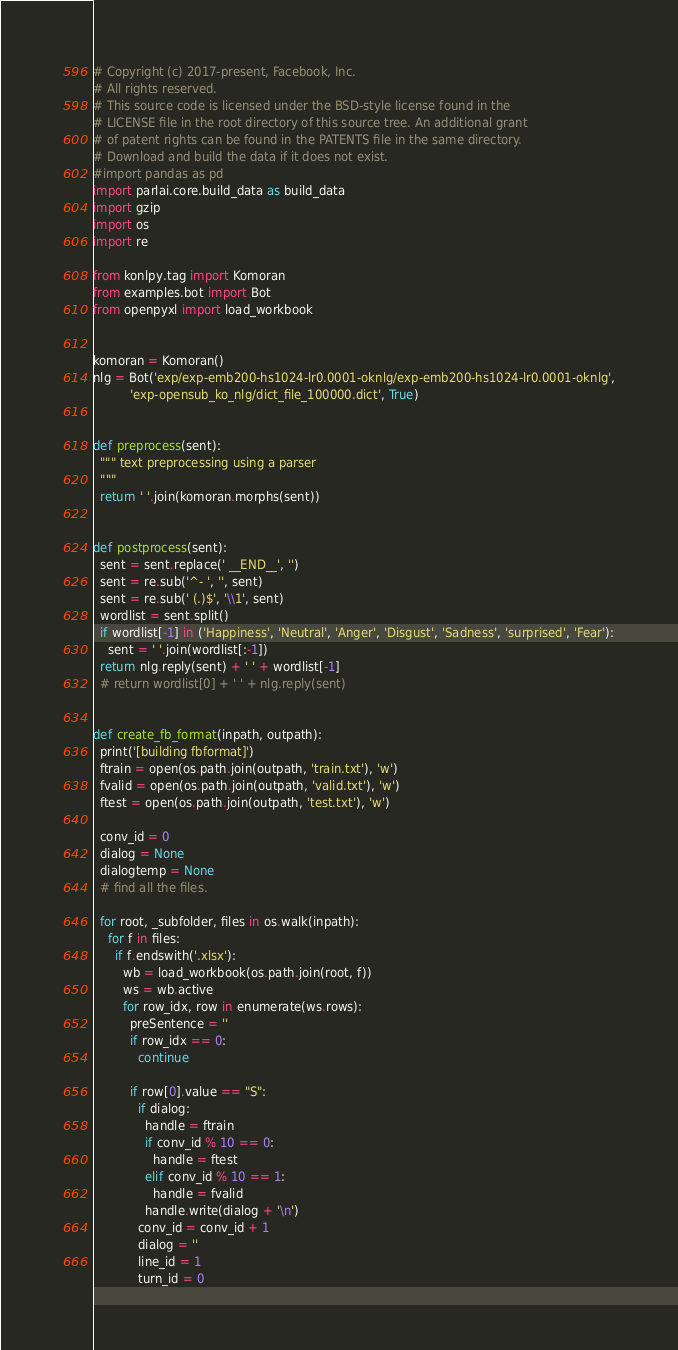Convert code to text. <code><loc_0><loc_0><loc_500><loc_500><_Python_># Copyright (c) 2017-present, Facebook, Inc.
# All rights reserved.
# This source code is licensed under the BSD-style license found in the
# LICENSE file in the root directory of this source tree. An additional grant
# of patent rights can be found in the PATENTS file in the same directory.
# Download and build the data if it does not exist.
#import pandas as pd
import parlai.core.build_data as build_data
import gzip
import os
import re

from konlpy.tag import Komoran
from examples.bot import Bot
from openpyxl import load_workbook


komoran = Komoran()
nlg = Bot('exp/exp-emb200-hs1024-lr0.0001-oknlg/exp-emb200-hs1024-lr0.0001-oknlg',
          'exp-opensub_ko_nlg/dict_file_100000.dict', True)


def preprocess(sent):
  """ text preprocessing using a parser
  """
  return ' '.join(komoran.morphs(sent))


def postprocess(sent):
  sent = sent.replace(' __END__', '')
  sent = re.sub('^- ', '', sent)
  sent = re.sub(' (.)$', '\\1', sent)
  wordlist = sent.split()
  if wordlist[-1] in ('Happiness', 'Neutral', 'Anger', 'Disgust', 'Sadness', 'surprised', 'Fear'):
    sent = ' '.join(wordlist[:-1])
  return nlg.reply(sent) + ' ' + wordlist[-1]
  # return wordlist[0] + ' ' + nlg.reply(sent)


def create_fb_format(inpath, outpath):
  print('[building fbformat]')
  ftrain = open(os.path.join(outpath, 'train.txt'), 'w')
  fvalid = open(os.path.join(outpath, 'valid.txt'), 'w')
  ftest = open(os.path.join(outpath, 'test.txt'), 'w')

  conv_id = 0
  dialog = None
  dialogtemp = None
  # find all the files.

  for root, _subfolder, files in os.walk(inpath):
    for f in files:
      if f.endswith('.xlsx'):
        wb = load_workbook(os.path.join(root, f))
        ws = wb.active
        for row_idx, row in enumerate(ws.rows):
          preSentence = ''
          if row_idx == 0:
            continue

          if row[0].value == "S":
            if dialog:
              handle = ftrain
              if conv_id % 10 == 0:
                handle = ftest
              elif conv_id % 10 == 1:
                handle = fvalid
              handle.write(dialog + '\n')
            conv_id = conv_id + 1
            dialog = ''
            line_id = 1
            turn_id = 0
</code> 